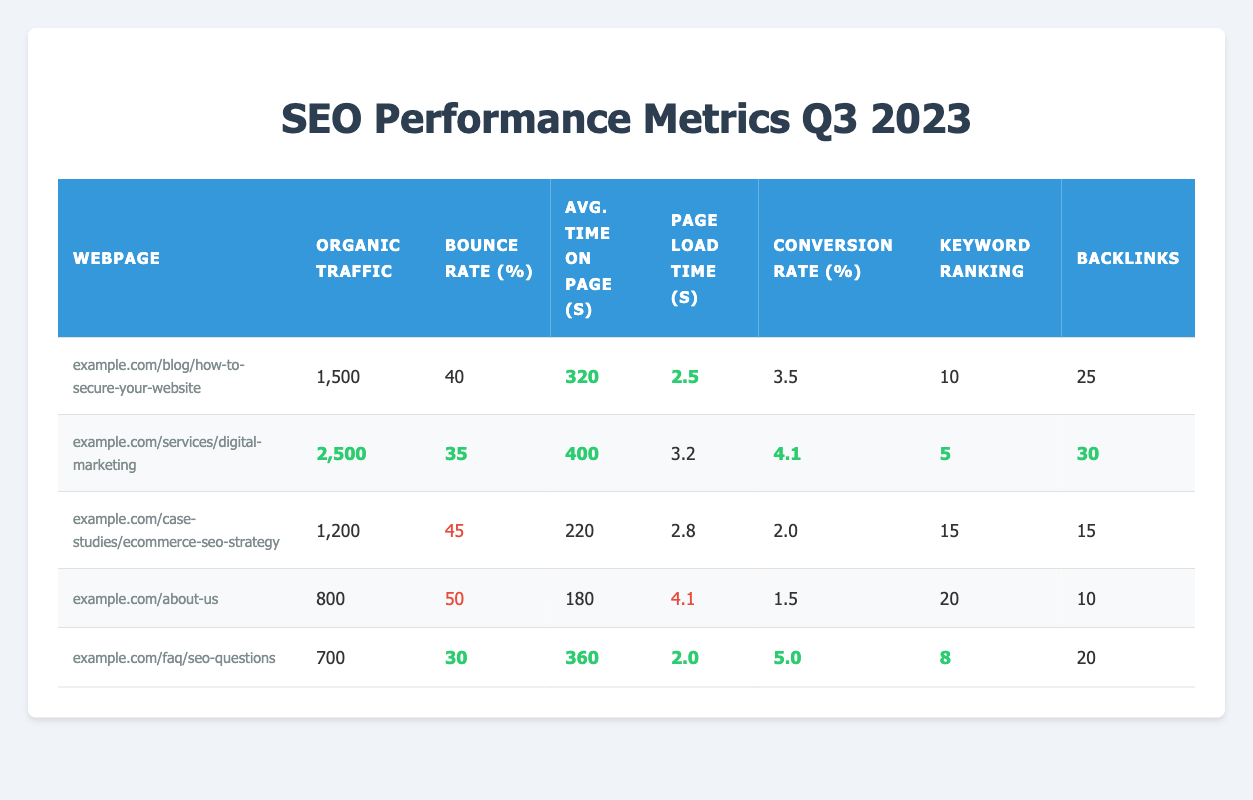What is the webpage with the highest organic traffic? By examining the "Organic Traffic" column, the webpage "example.com/services/digital-marketing" has the highest value at 2500.
Answer: example.com/services/digital-marketing What is the average bounce rate across all webpages? First, sum the bounce rates: 40 + 35 + 45 + 50 + 30 = 200. Then, divide by the number of webpages (5): 200 / 5 = 40.
Answer: 40 Which webpage has the lowest conversion rate? By looking at the "Conversion Rate" column, "example.com/about-us" has the lowest value at 1.5%.
Answer: example.com/about-us How many backlinks does the webpage "example.com/blog/how-to-secure-your-website" have? Directly refer to the "Backlinks" column for this webpage, which shows a value of 25 backlinks.
Answer: 25 Is the average time on page for "example.com/faq/seo-questions" greater than or equal to 350 seconds? The "Average Time on Page" for "example.com/faq/seo-questions" is 360 seconds, which is greater than 350 seconds.
Answer: Yes What is the total organic traffic for all webpages combined? Sum the organic traffic values: 1500 + 2500 + 1200 + 800 + 700 = 6700.
Answer: 6700 Which webpage features the best keyword ranking? Evaluating the "Keyword Ranking" column, "example.com/services/digital-marketing" ranks 5, which is the best compared to others.
Answer: example.com/services/digital-marketing Compare the page load times: which one is faster, "example.com/case-studies/ecommerce-seo-strategy" or "example.com/about-us"? The page load time for "example.com/case-studies/ecommerce-seo-strategy" is 2.8 seconds and for "example.com/about-us" is 4.1 seconds; thus, the former is faster.
Answer: example.com/case-studies/ecommerce-seo-strategy How many pages have a bounce rate below 40%? The webpages "example.com/services/digital-marketing" (35%) and "example.com/faq/seo-questions" (30%) have bounce rates below 40%. Thus, there are 2 pages.
Answer: 2 What is the difference in average time on page between "example.com/blog/how-to-secure-your-website" and "example.com/about-us"? The average time on page for "example.com/blog/how-to-secure-your-website" is 320 seconds, and for "example.com/about-us" is 180 seconds. The difference is 320 - 180 = 140 seconds.
Answer: 140 seconds 